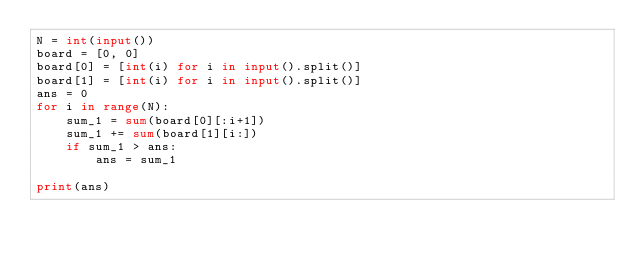Convert code to text. <code><loc_0><loc_0><loc_500><loc_500><_Python_>N = int(input())
board = [0, 0]
board[0] = [int(i) for i in input().split()]
board[1] = [int(i) for i in input().split()]
ans = 0
for i in range(N):
    sum_1 = sum(board[0][:i+1])
    sum_1 += sum(board[1][i:])
    if sum_1 > ans:
        ans = sum_1

print(ans)</code> 